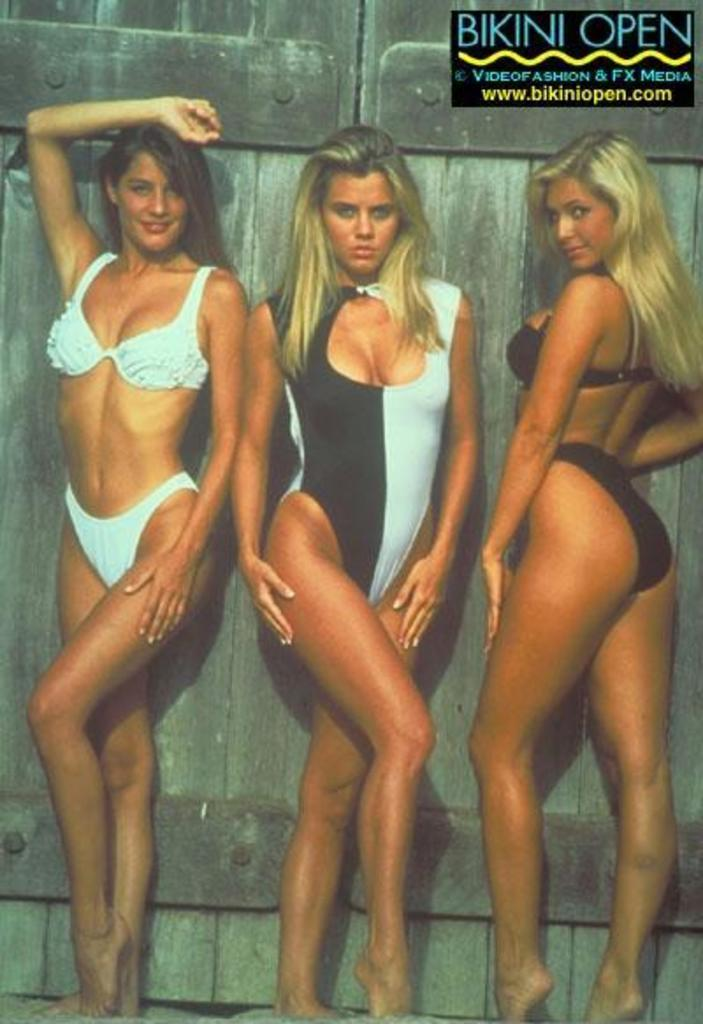How many people are present in the image? There are three women standing in the image. Can you describe the background of the image? There is a wood door in the background of the image. What type of cactus can be seen in the image? There is no cactus present in the image. What subject are the women teaching in the image? There is no indication in the image that the women are teaching any subject. 